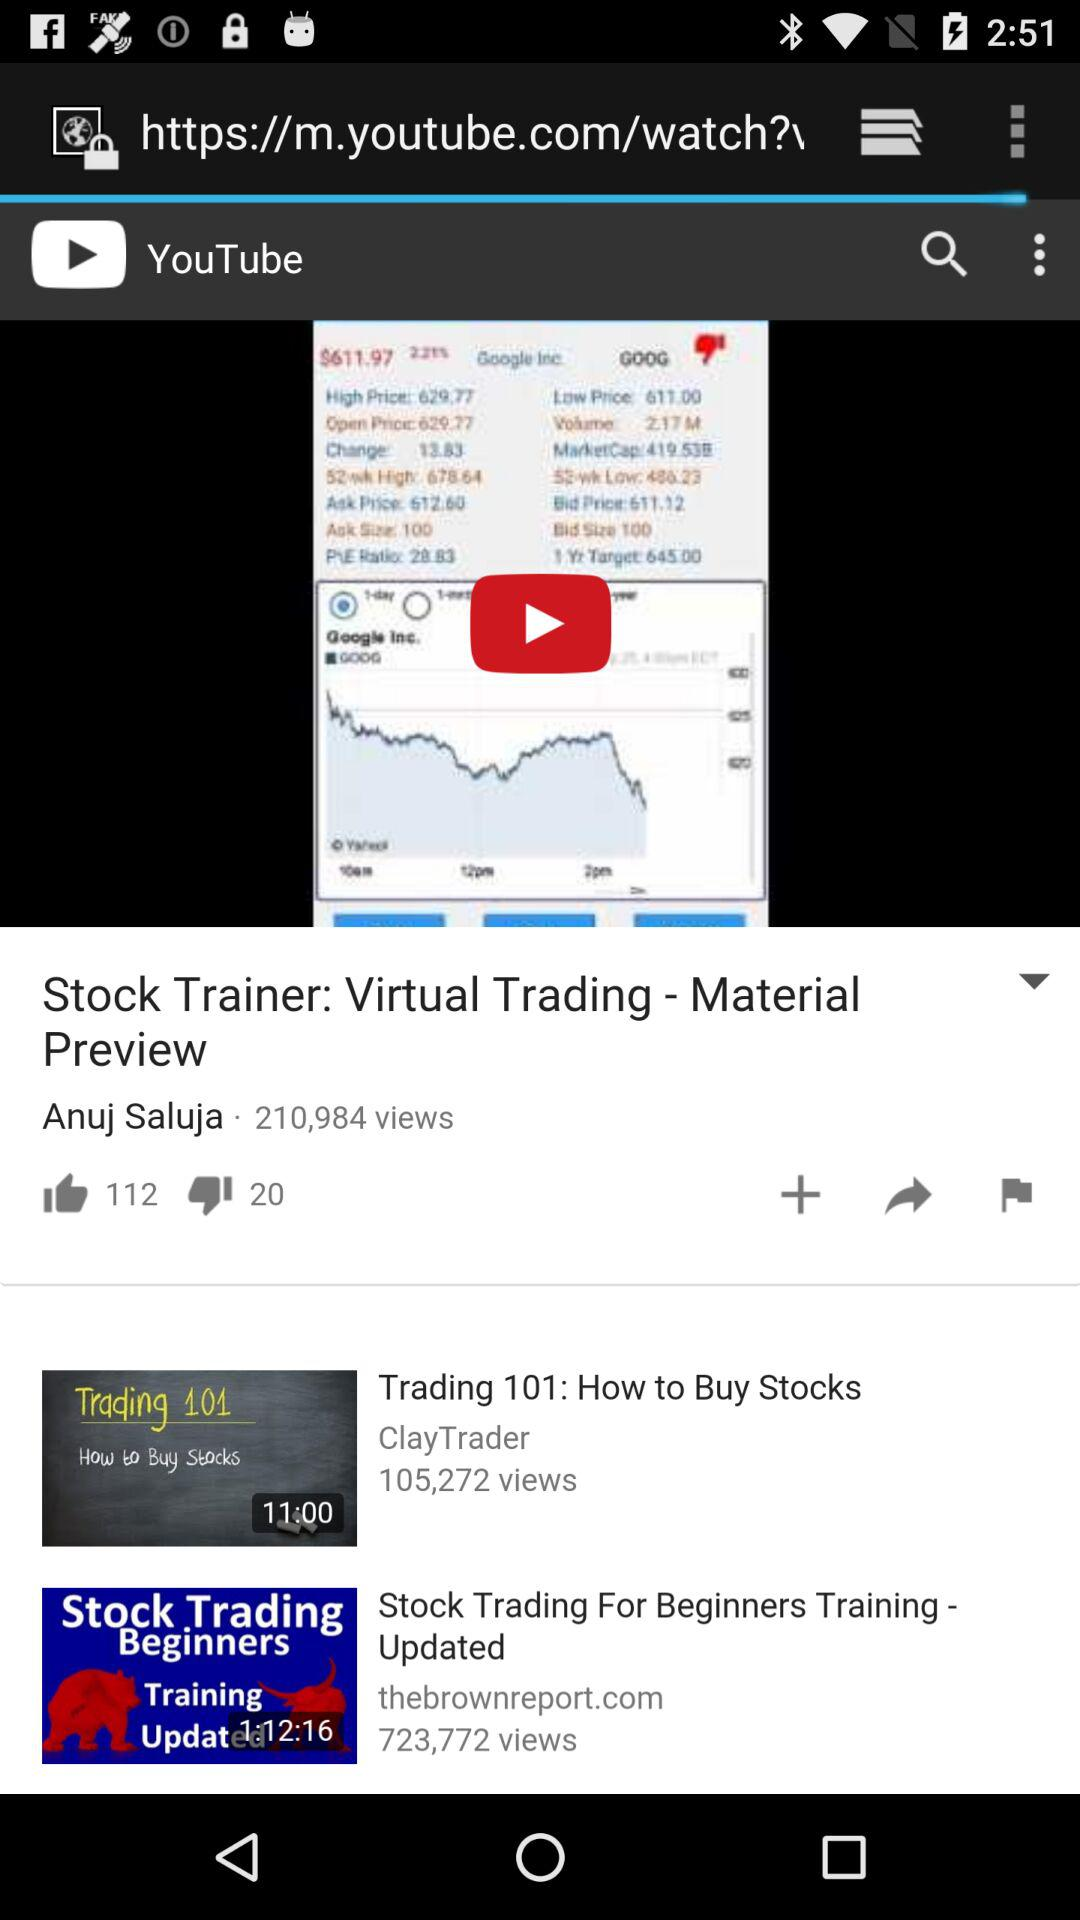What is the name of the video that Anuj Saluja shared?
Answer the question using a single word or phrase. The name of the video that Anuj Salija shared is Stock Trainer: Virtual Trading - Material Preview 